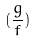Convert formula to latex. <formula><loc_0><loc_0><loc_500><loc_500>( \frac { g } { f } )</formula> 